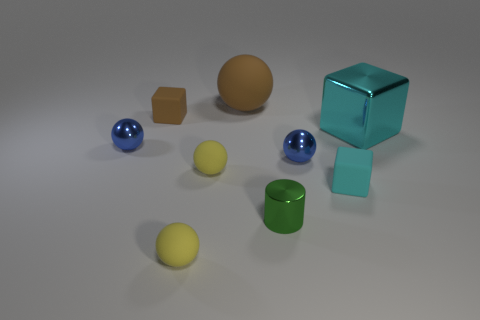Subtract all gray cylinders. How many yellow spheres are left? 2 Subtract all small yellow spheres. How many spheres are left? 3 Subtract all brown spheres. How many spheres are left? 4 Subtract 2 spheres. How many spheres are left? 3 Add 1 large blue rubber blocks. How many objects exist? 10 Subtract all gray balls. Subtract all blue cylinders. How many balls are left? 5 Subtract all spheres. How many objects are left? 4 Add 2 spheres. How many spheres are left? 7 Add 2 gray matte balls. How many gray matte balls exist? 2 Subtract 0 gray cylinders. How many objects are left? 9 